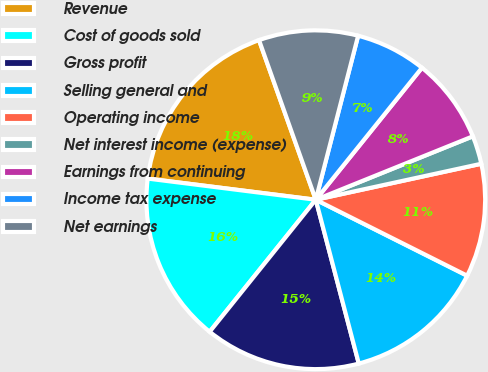<chart> <loc_0><loc_0><loc_500><loc_500><pie_chart><fcel>Revenue<fcel>Cost of goods sold<fcel>Gross profit<fcel>Selling general and<fcel>Operating income<fcel>Net interest income (expense)<fcel>Earnings from continuing<fcel>Income tax expense<fcel>Net earnings<nl><fcel>17.57%<fcel>16.22%<fcel>14.86%<fcel>13.51%<fcel>10.81%<fcel>2.7%<fcel>8.11%<fcel>6.76%<fcel>9.46%<nl></chart> 